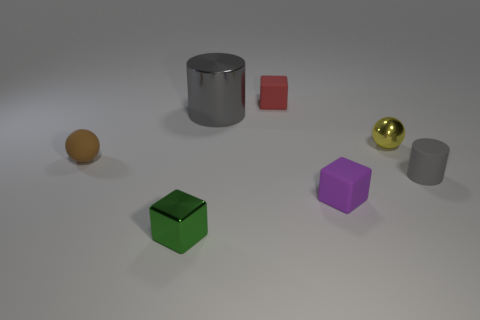What is the color of the rubber ball that is the same size as the rubber cylinder?
Provide a succinct answer. Brown. Are there any balls of the same color as the matte cylinder?
Provide a succinct answer. No. How many things are either small things behind the big gray metallic object or tiny metallic cubes?
Offer a terse response. 2. How many other things are there of the same size as the red rubber object?
Make the answer very short. 5. There is a gray thing in front of the sphere that is in front of the ball that is to the right of the gray metal cylinder; what is it made of?
Provide a succinct answer. Rubber. How many cylinders are tiny brown matte objects or small yellow things?
Your answer should be compact. 0. Is there anything else that has the same shape as the small brown matte object?
Offer a very short reply. Yes. Are there more purple blocks behind the gray shiny thing than big gray cylinders that are in front of the purple thing?
Your answer should be compact. No. There is a gray thing behind the small brown thing; what number of green objects are on the right side of it?
Your response must be concise. 0. What number of things are either tiny spheres or small red blocks?
Make the answer very short. 3. 